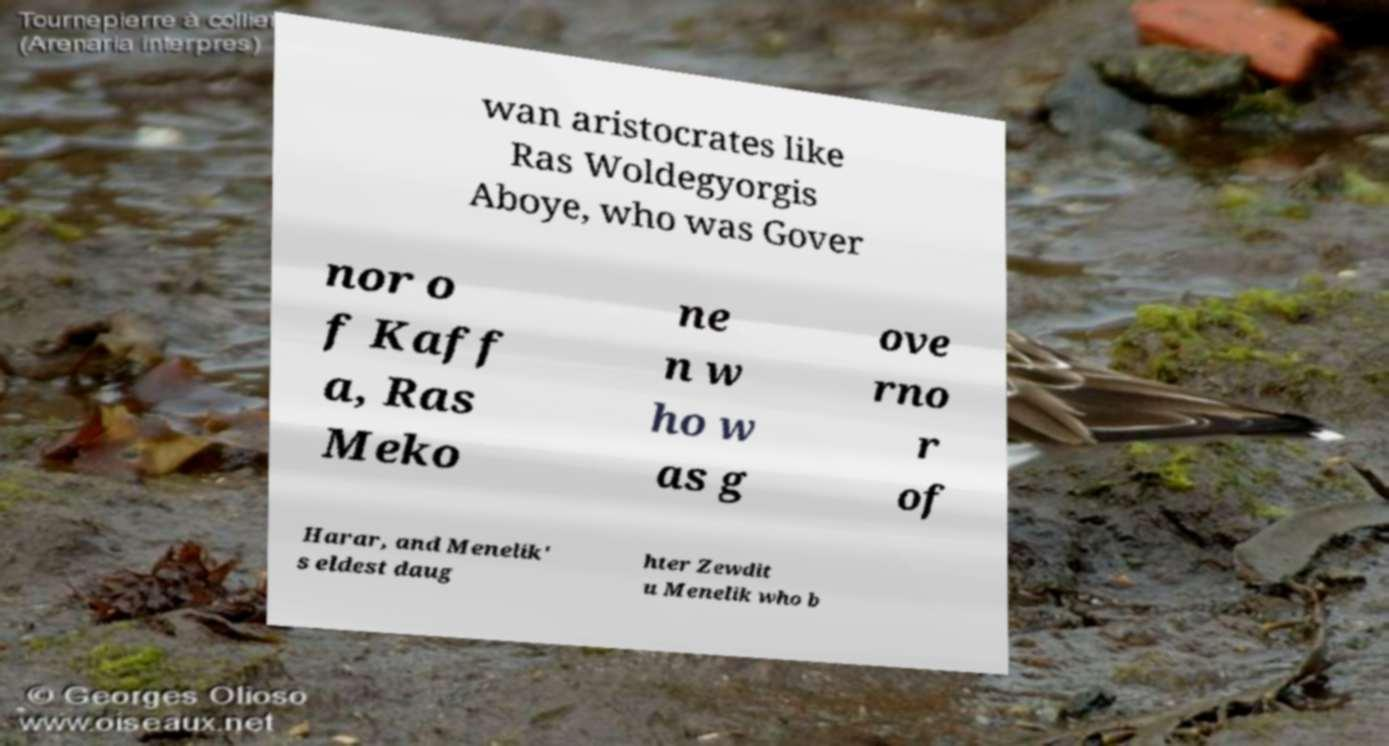Could you extract and type out the text from this image? wan aristocrates like Ras Woldegyorgis Aboye, who was Gover nor o f Kaff a, Ras Meko ne n w ho w as g ove rno r of Harar, and Menelik' s eldest daug hter Zewdit u Menelik who b 